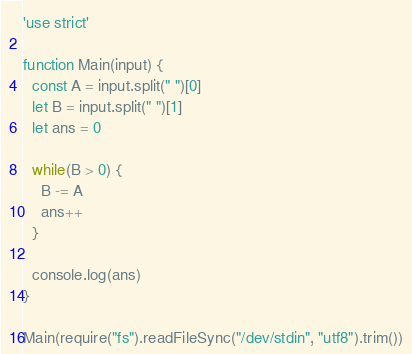<code> <loc_0><loc_0><loc_500><loc_500><_JavaScript_>'use strict'

function Main(input) {
  const A = input.split(" ")[0]
  let B = input.split(" ")[1]
  let ans = 0

  while(B > 0) {
    B -= A
    ans++
  }

  console.log(ans)
}

Main(require("fs").readFileSync("/dev/stdin", "utf8").trim())
</code> 